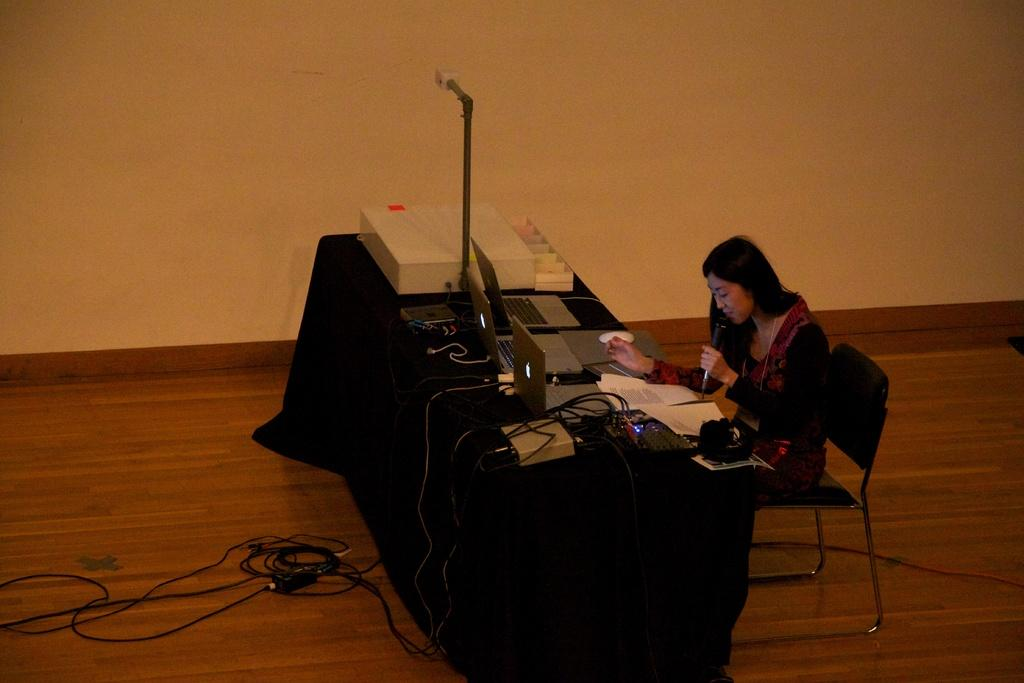What is the woman in the image doing? The woman is sitting on a chair in the image. What is in front of the woman? There is a table in front of the woman. What can be seen on the table? There is a printing machine, laptops, cables, and a tablecloth on the table. Can you see any icicles hanging from the printing machine in the image? There are no icicles present in the image; it is an indoor setting with a printing machine, laptops, cables, and a tablecloth on the table. 